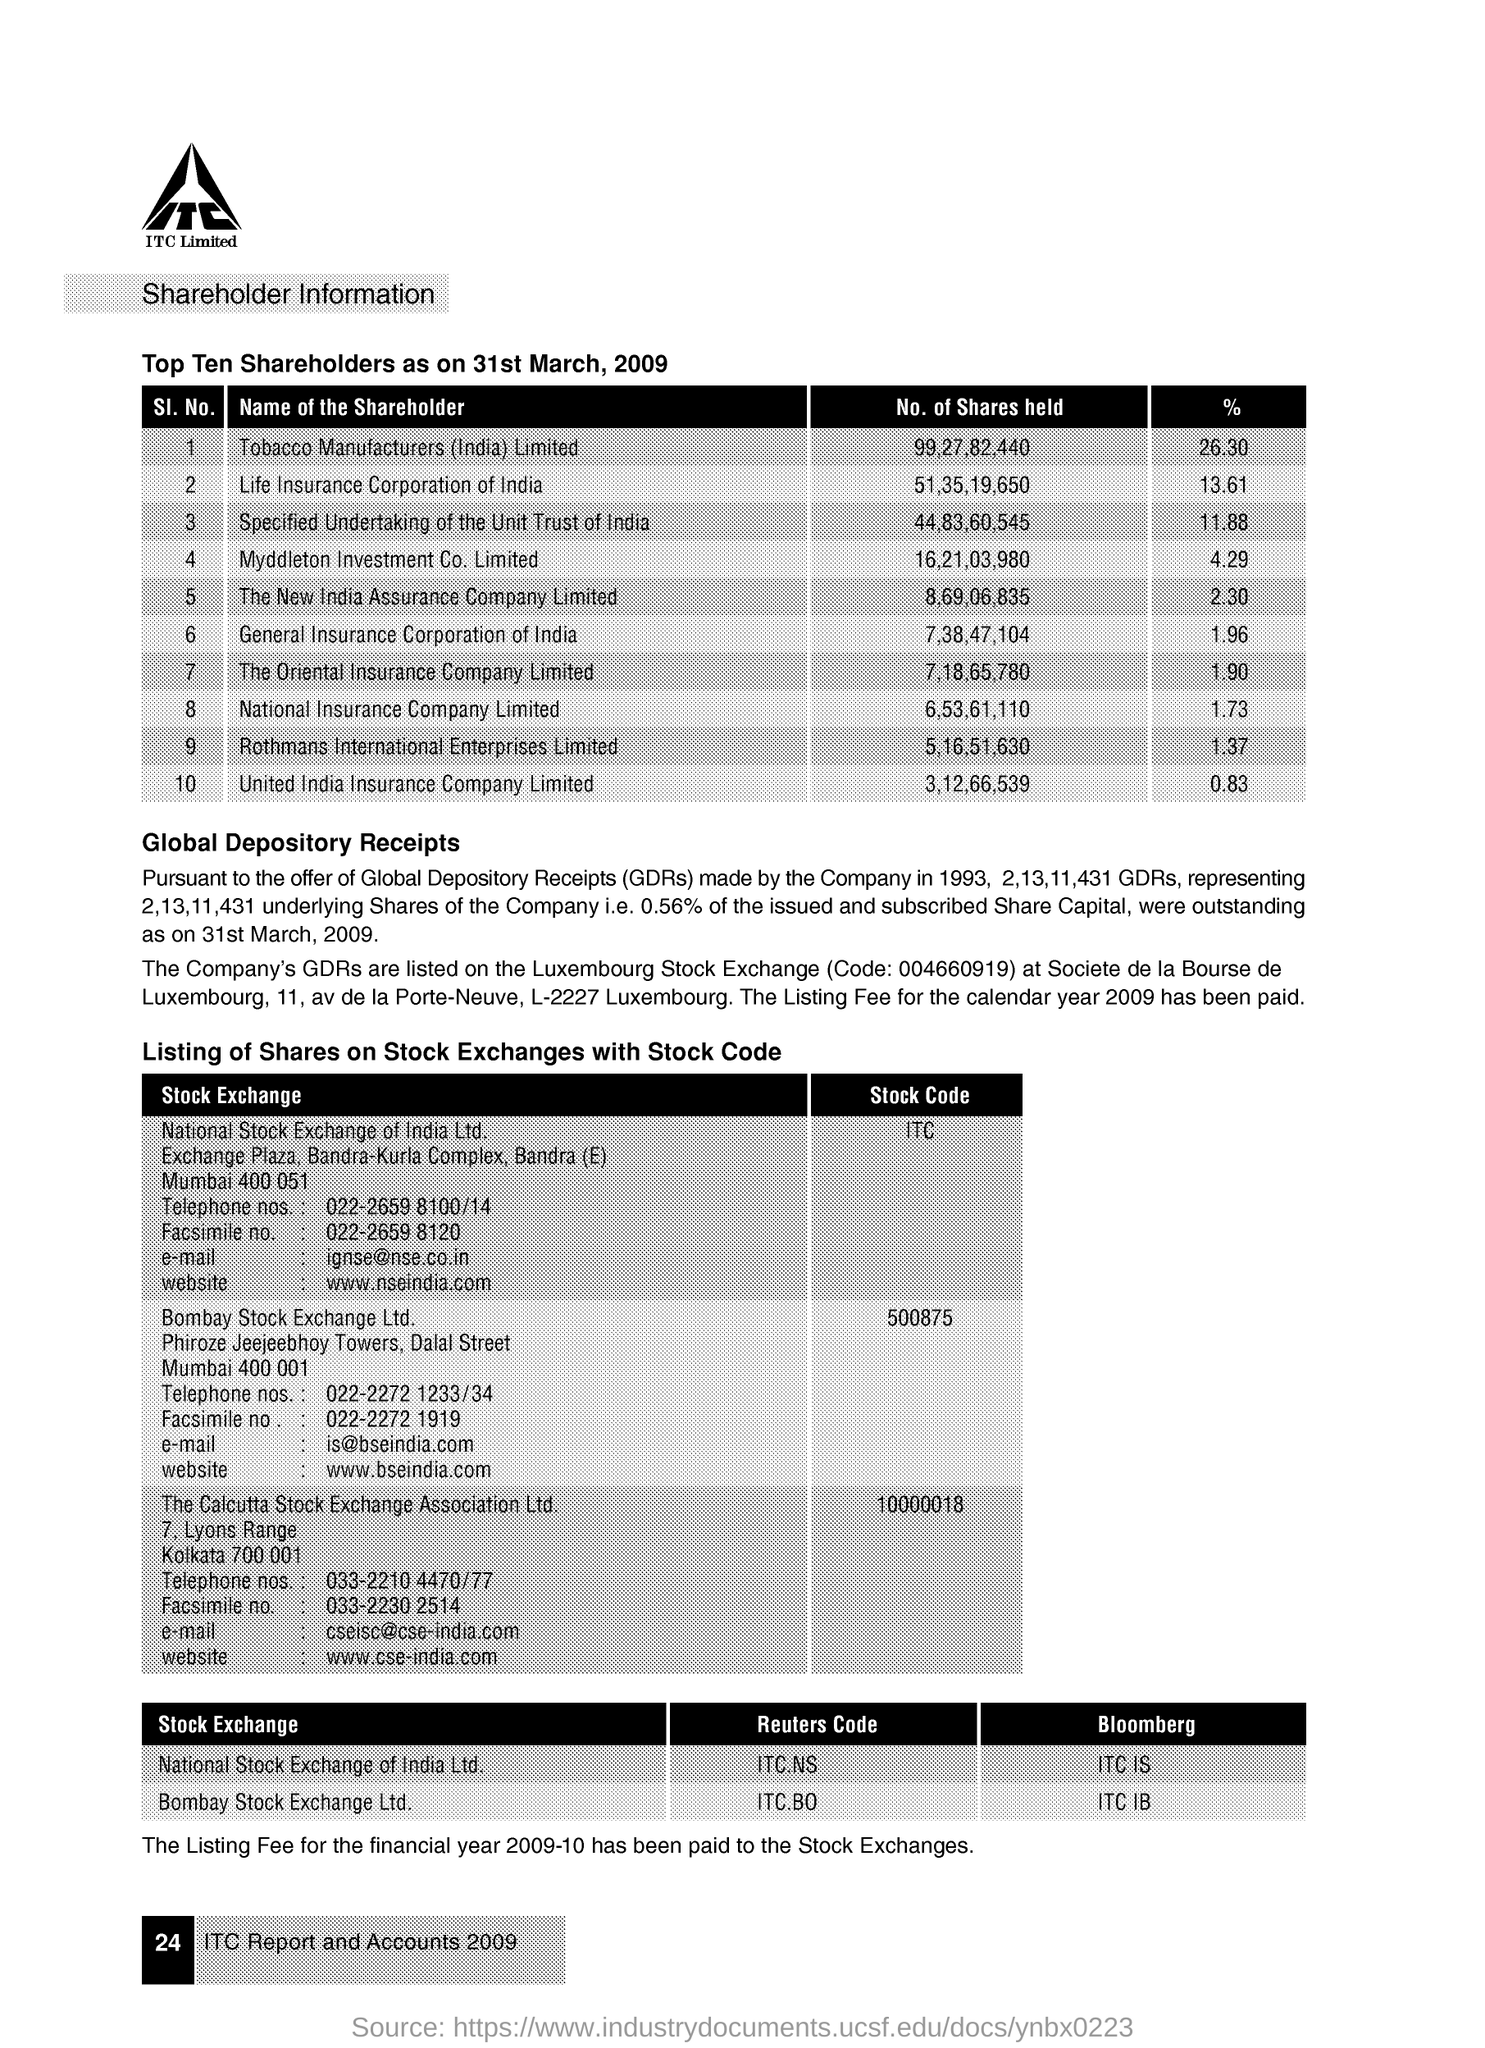Specify some key components in this picture. The stock code of Bombay Stock Exchange Ltd is 500875. The percentage of tobacco manufacturers in India is 26.30%. The stock code of the National Stock Exchange of India Ltd. is ITC. Global Depository Receipts are a type of financial instrument that are traded on stock exchanges and are issued by companies to raise capital in foreign markets. 